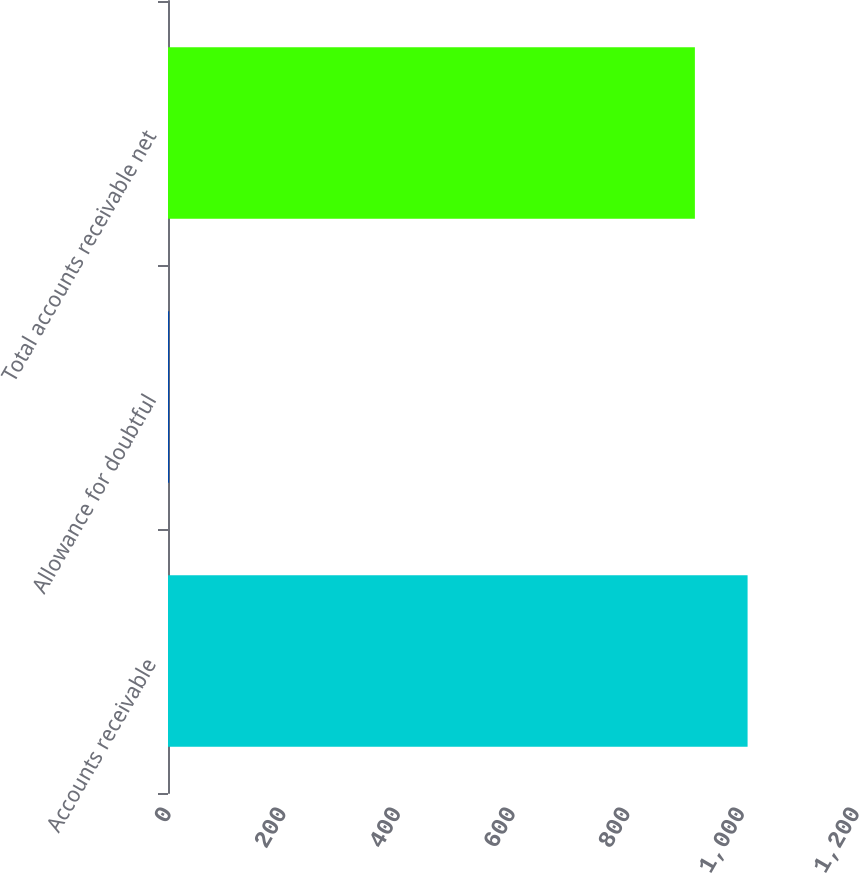Convert chart. <chart><loc_0><loc_0><loc_500><loc_500><bar_chart><fcel>Accounts receivable<fcel>Allowance for doubtful<fcel>Total accounts receivable net<nl><fcel>1010.9<fcel>2<fcel>919<nl></chart> 